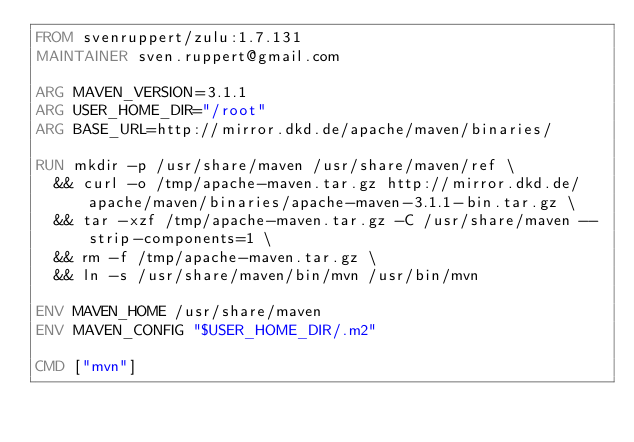<code> <loc_0><loc_0><loc_500><loc_500><_Dockerfile_>FROM svenruppert/zulu:1.7.131
MAINTAINER sven.ruppert@gmail.com

ARG MAVEN_VERSION=3.1.1
ARG USER_HOME_DIR="/root"
ARG BASE_URL=http://mirror.dkd.de/apache/maven/binaries/

RUN mkdir -p /usr/share/maven /usr/share/maven/ref \
  && curl -o /tmp/apache-maven.tar.gz http://mirror.dkd.de/apache/maven/binaries/apache-maven-3.1.1-bin.tar.gz \
  && tar -xzf /tmp/apache-maven.tar.gz -C /usr/share/maven --strip-components=1 \
  && rm -f /tmp/apache-maven.tar.gz \
  && ln -s /usr/share/maven/bin/mvn /usr/bin/mvn

ENV MAVEN_HOME /usr/share/maven
ENV MAVEN_CONFIG "$USER_HOME_DIR/.m2"

CMD ["mvn"]</code> 